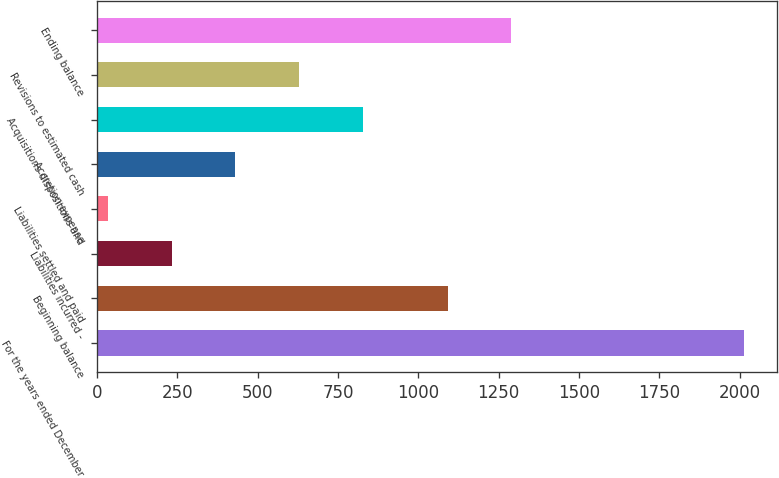Convert chart. <chart><loc_0><loc_0><loc_500><loc_500><bar_chart><fcel>For the years ended December<fcel>Beginning balance<fcel>Liabilities incurred -<fcel>Liabilities settled and paid<fcel>Accretion expense<fcel>Acquisitions dispositions and<fcel>Revisions to estimated cash<fcel>Ending balance<nl><fcel>2015<fcel>1091<fcel>233<fcel>35<fcel>431<fcel>827<fcel>629<fcel>1289<nl></chart> 